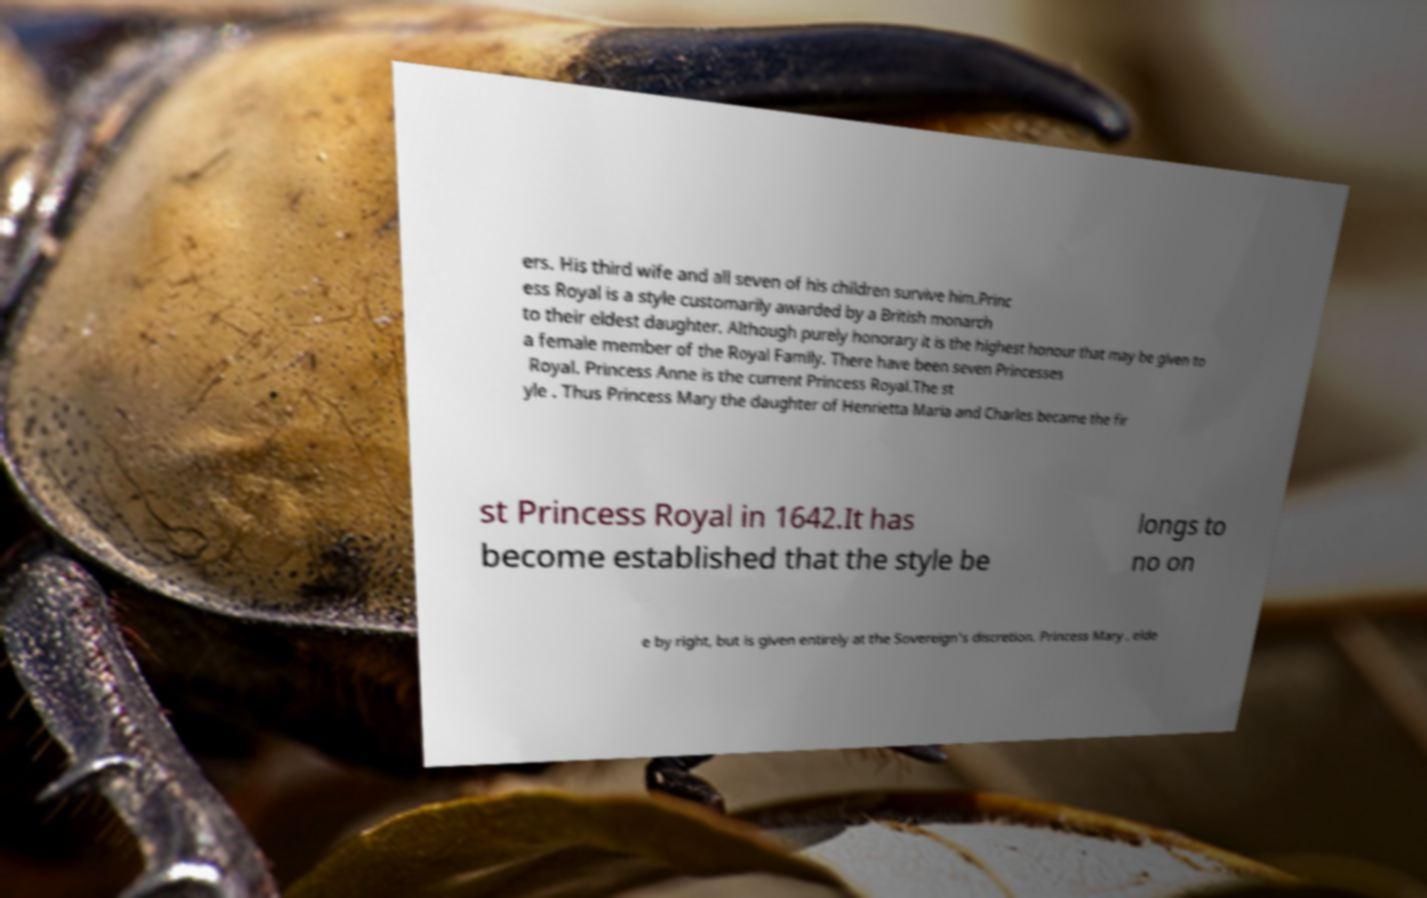Please read and relay the text visible in this image. What does it say? ers. His third wife and all seven of his children survive him.Princ ess Royal is a style customarily awarded by a British monarch to their eldest daughter. Although purely honorary it is the highest honour that may be given to a female member of the Royal Family. There have been seven Princesses Royal. Princess Anne is the current Princess Royal.The st yle . Thus Princess Mary the daughter of Henrietta Maria and Charles became the fir st Princess Royal in 1642.It has become established that the style be longs to no on e by right, but is given entirely at the Sovereign's discretion. Princess Mary , elde 